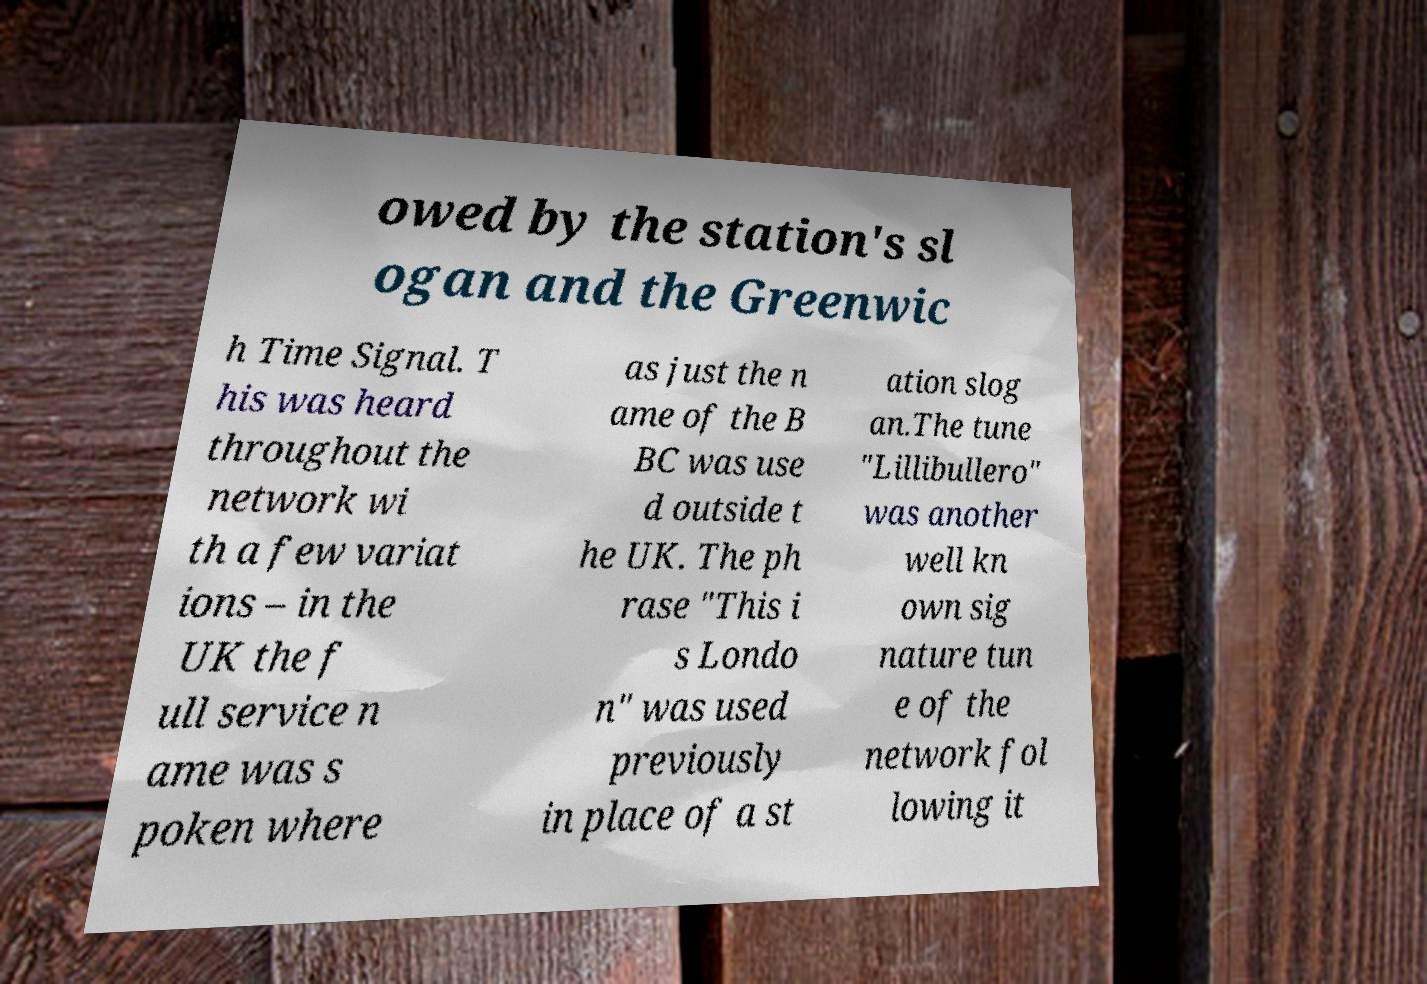Please identify and transcribe the text found in this image. owed by the station's sl ogan and the Greenwic h Time Signal. T his was heard throughout the network wi th a few variat ions – in the UK the f ull service n ame was s poken where as just the n ame of the B BC was use d outside t he UK. The ph rase "This i s Londo n" was used previously in place of a st ation slog an.The tune "Lillibullero" was another well kn own sig nature tun e of the network fol lowing it 